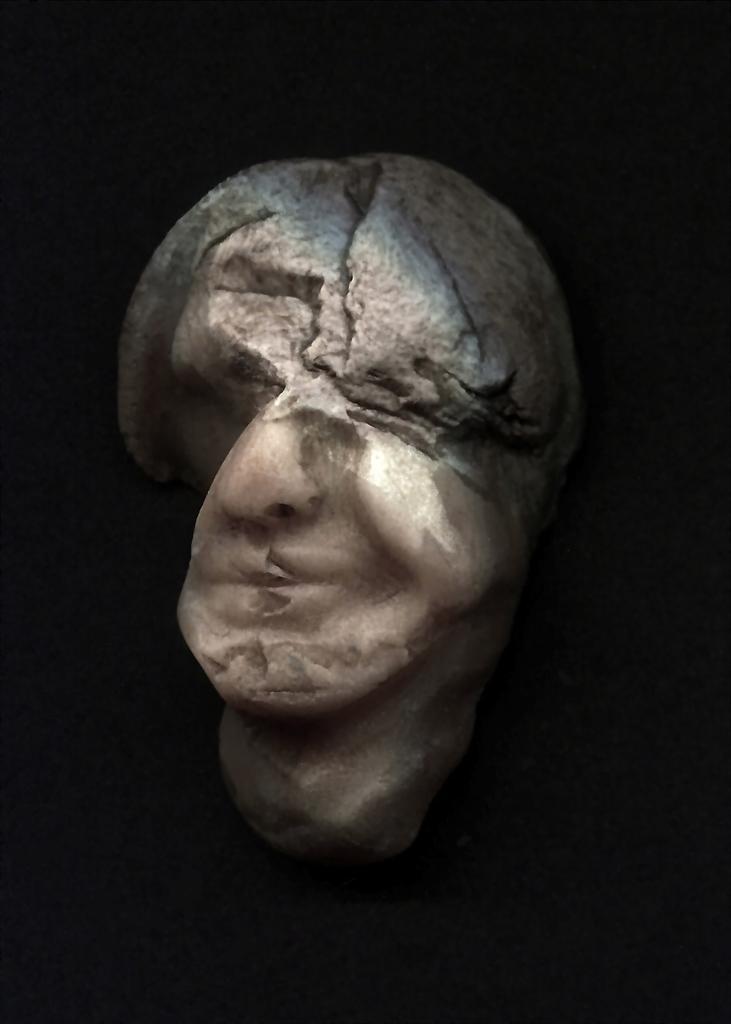How would you summarize this image in a sentence or two? In this image there is a stone sculpture , and there is dark background. 